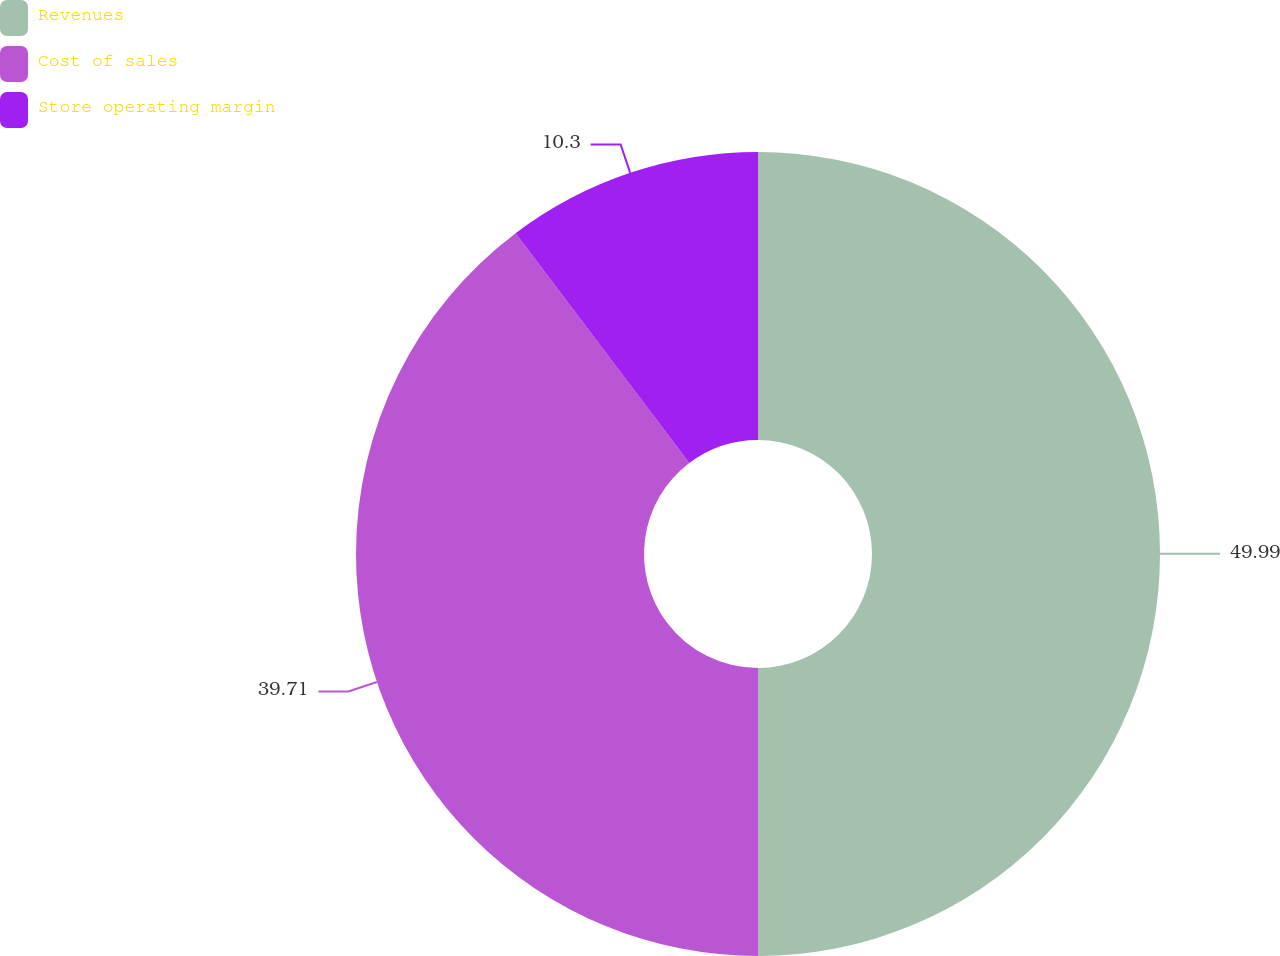<chart> <loc_0><loc_0><loc_500><loc_500><pie_chart><fcel>Revenues<fcel>Cost of sales<fcel>Store operating margin<nl><fcel>49.99%<fcel>39.71%<fcel>10.3%<nl></chart> 